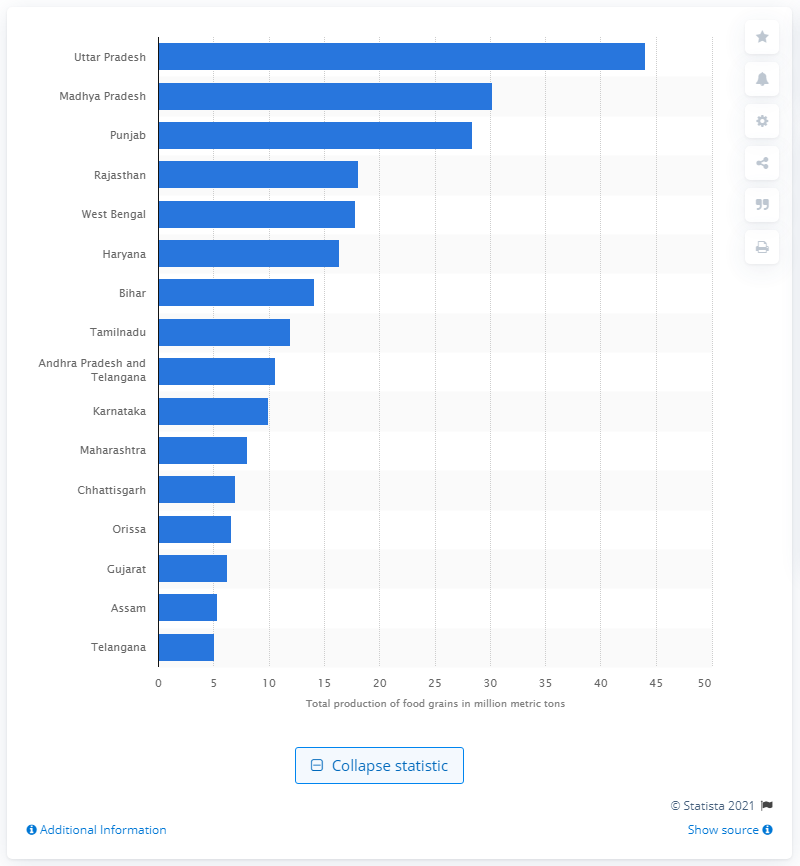Identify some key points in this picture. Uttar Pradesh produced 44.01 metric tons of food grains in 2016. 